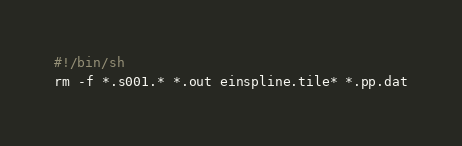<code> <loc_0><loc_0><loc_500><loc_500><_Bash_>#!/bin/sh
rm -f *.s001.* *.out einspline.tile* *.pp.dat

</code> 